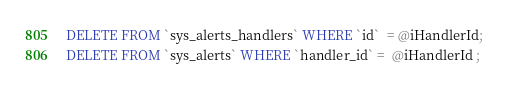<code> <loc_0><loc_0><loc_500><loc_500><_SQL_>
DELETE FROM `sys_alerts_handlers` WHERE `id`  = @iHandlerId;
DELETE FROM `sys_alerts` WHERE `handler_id` =  @iHandlerId ;
</code> 